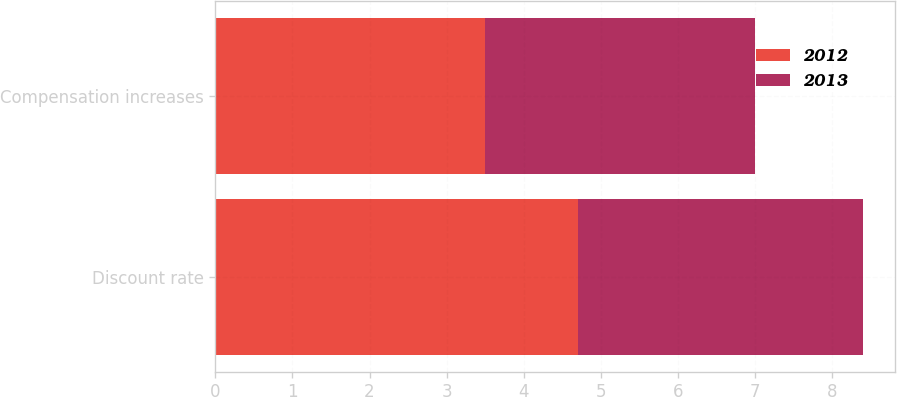Convert chart to OTSL. <chart><loc_0><loc_0><loc_500><loc_500><stacked_bar_chart><ecel><fcel>Discount rate<fcel>Compensation increases<nl><fcel>2012<fcel>4.7<fcel>3.5<nl><fcel>2013<fcel>3.7<fcel>3.5<nl></chart> 